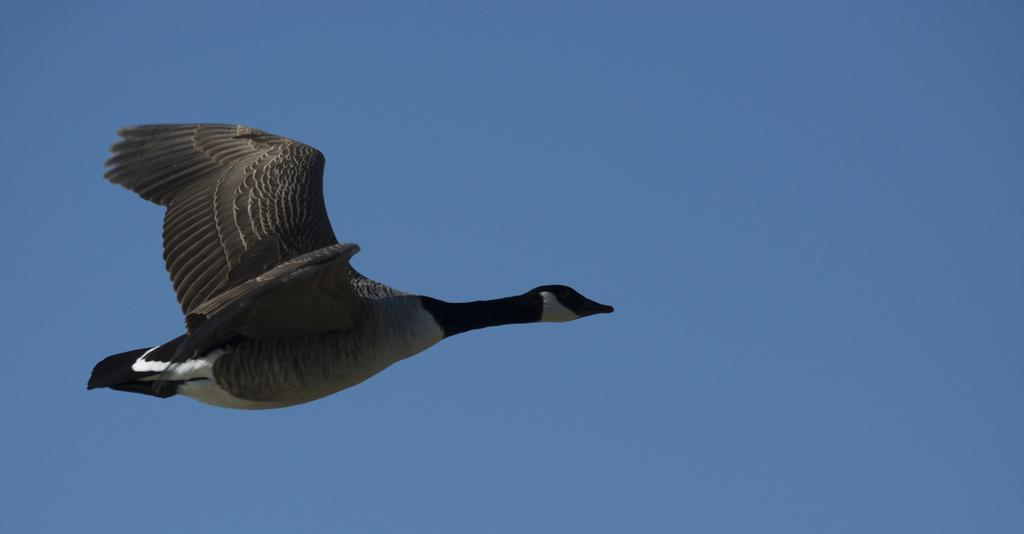What type of animal can be seen in the image? There is a bird in the image. What is the bird doing in the image? The bird is flying in the sky. What is the bird's limit in the image? There is no reference to a limit in the image; it simply shows a bird flying in the sky. How many trips has the bird taken in the image? There is no indication of the bird taking any trips in the image; it is simply flying in the sky. 